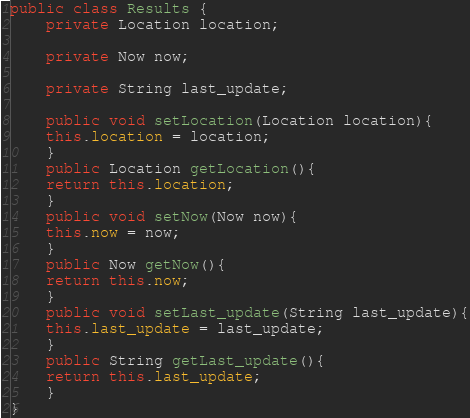Convert code to text. <code><loc_0><loc_0><loc_500><loc_500><_Java_>public class Results {
	private Location location;

	private Now now;

	private String last_update;

	public void setLocation(Location location){
	this.location = location;
	}
	public Location getLocation(){
	return this.location;
	}
	public void setNow(Now now){
	this.now = now;
	}
	public Now getNow(){
	return this.now;
	}
	public void setLast_update(String last_update){
	this.last_update = last_update;
	}
	public String getLast_update(){
	return this.last_update;
	}
}
</code> 